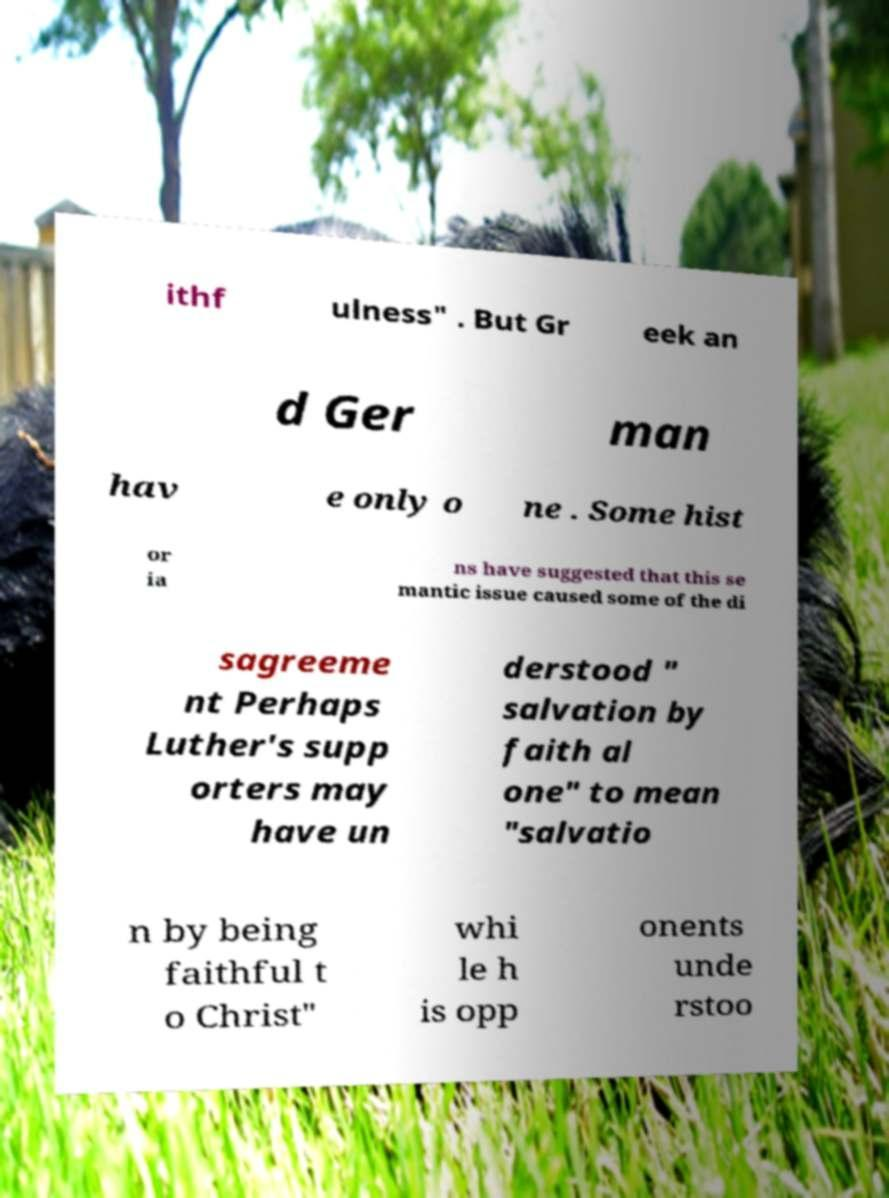For documentation purposes, I need the text within this image transcribed. Could you provide that? ithf ulness" . But Gr eek an d Ger man hav e only o ne . Some hist or ia ns have suggested that this se mantic issue caused some of the di sagreeme nt Perhaps Luther's supp orters may have un derstood " salvation by faith al one" to mean "salvatio n by being faithful t o Christ" whi le h is opp onents unde rstoo 